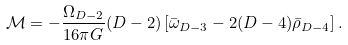<formula> <loc_0><loc_0><loc_500><loc_500>\mathcal { M } = - \frac { \Omega _ { D - 2 } } { 1 6 \pi G } ( D - 2 ) \left [ \bar { \omega } _ { D - 3 } - 2 ( D - 4 ) \bar { \rho } _ { D - 4 } \right ] .</formula> 